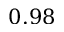Convert formula to latex. <formula><loc_0><loc_0><loc_500><loc_500>0 . 9 8</formula> 